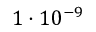Convert formula to latex. <formula><loc_0><loc_0><loc_500><loc_500>1 \cdot 1 0 ^ { - 9 }</formula> 